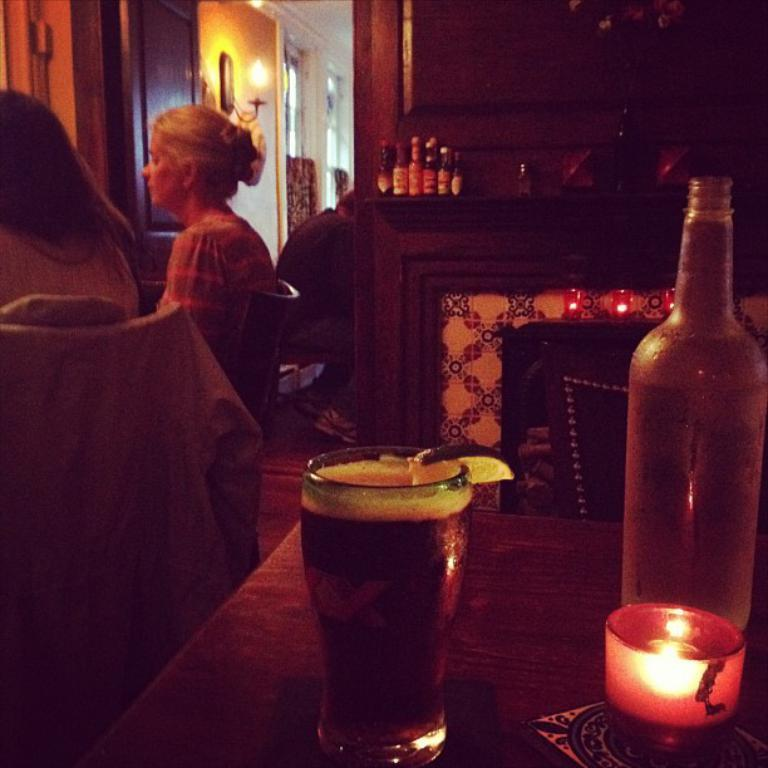How many persons are sitting in chairs in the image? There are two persons sitting in chairs in the image. What can be seen on the table in the background? There are bottles on a table in the background. What else is on the table besides the bottles? There is another bottle, a glass, and a candle on the table. What type of lighting is present in the image? There is a lamp in the image. How much did the persons in the image agree on during their discussion? There is no discussion taking place in the image, so it is impossible to determine how much they agreed on. 